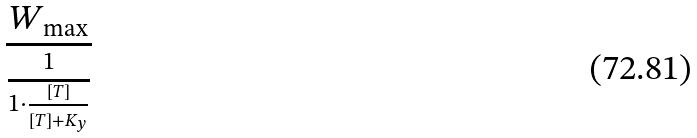<formula> <loc_0><loc_0><loc_500><loc_500>\frac { W _ { \max } } { \frac { 1 } { 1 \cdot \frac { [ T ] } { [ T ] + K _ { y } } } }</formula> 